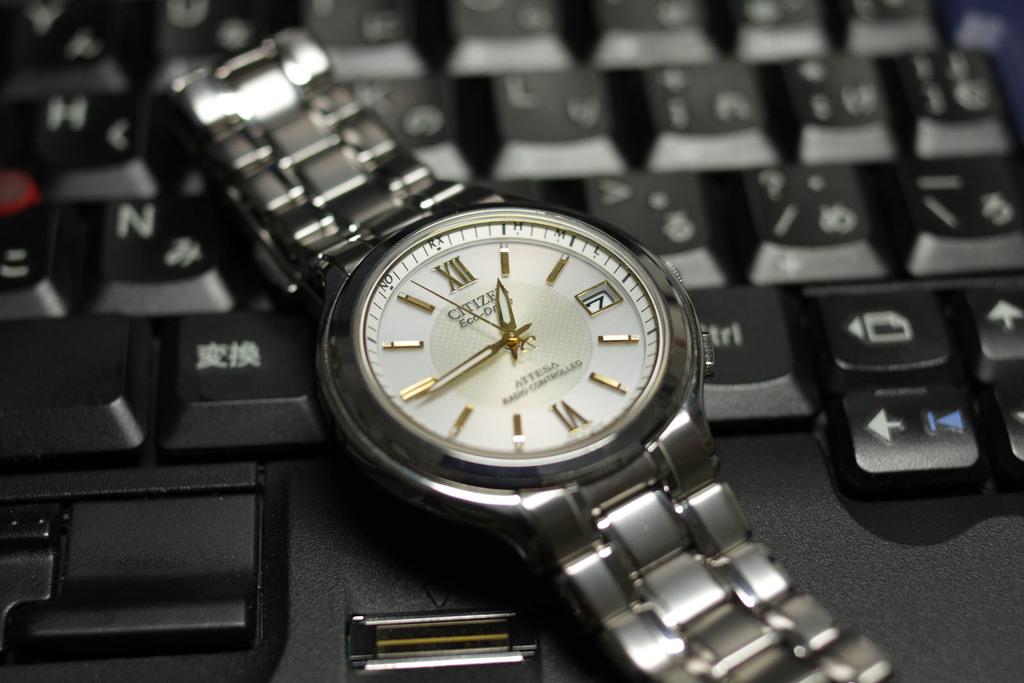What time is it?
Offer a terse response. 12:44. What time is it?
Keep it short and to the point. 12:45. 